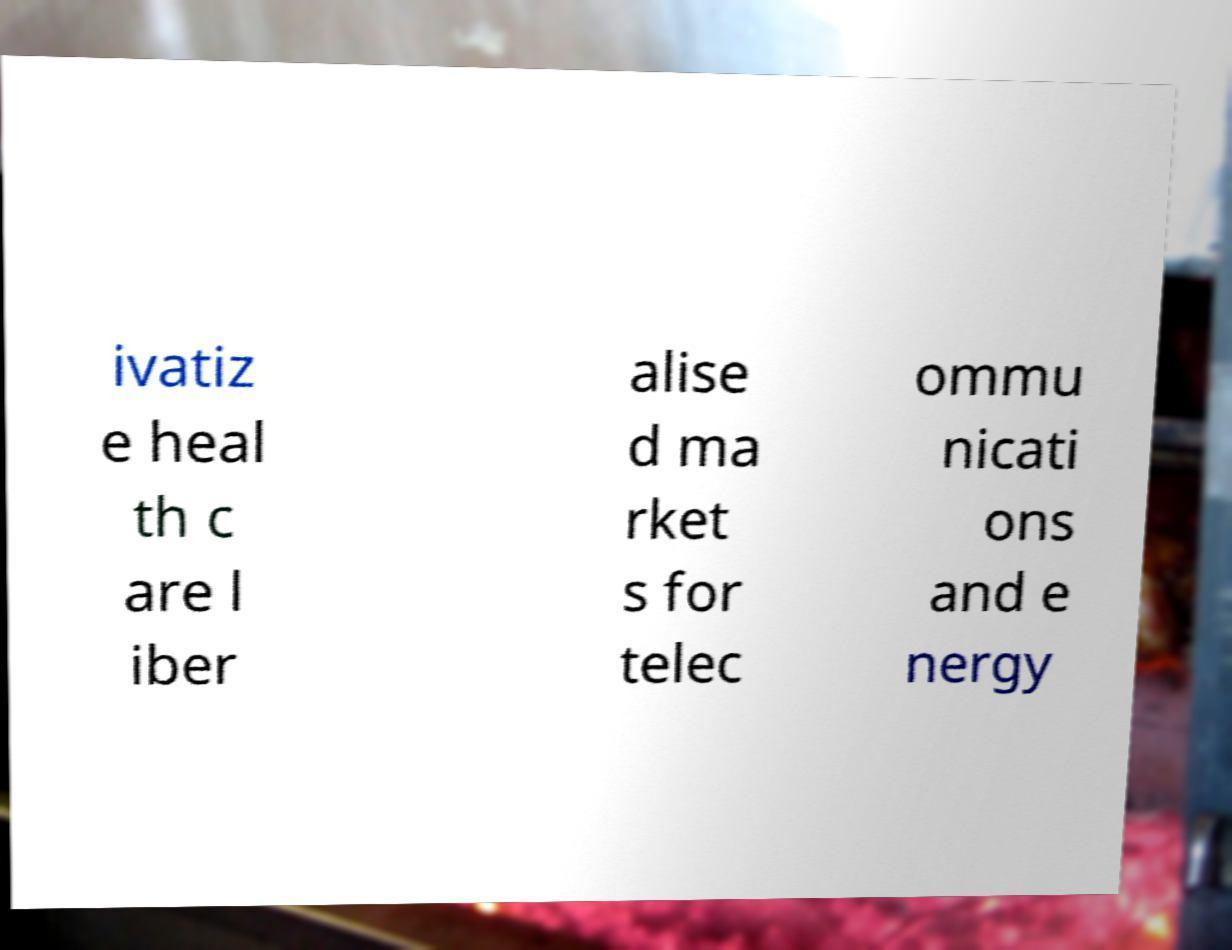Could you assist in decoding the text presented in this image and type it out clearly? ivatiz e heal th c are l iber alise d ma rket s for telec ommu nicati ons and e nergy 